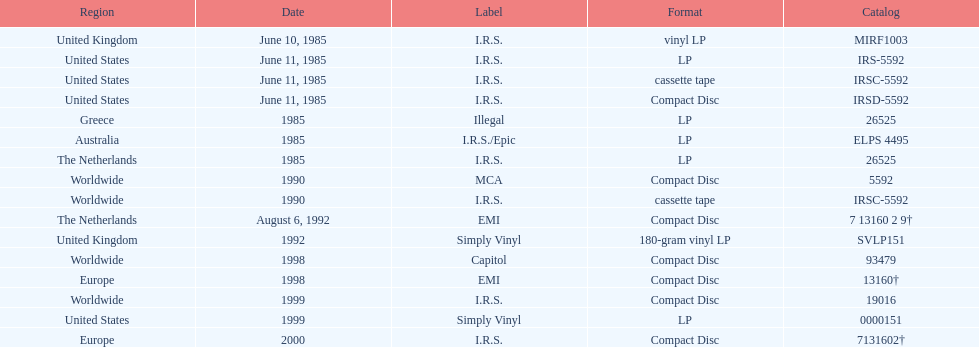Which area was the final to launch? Europe. 